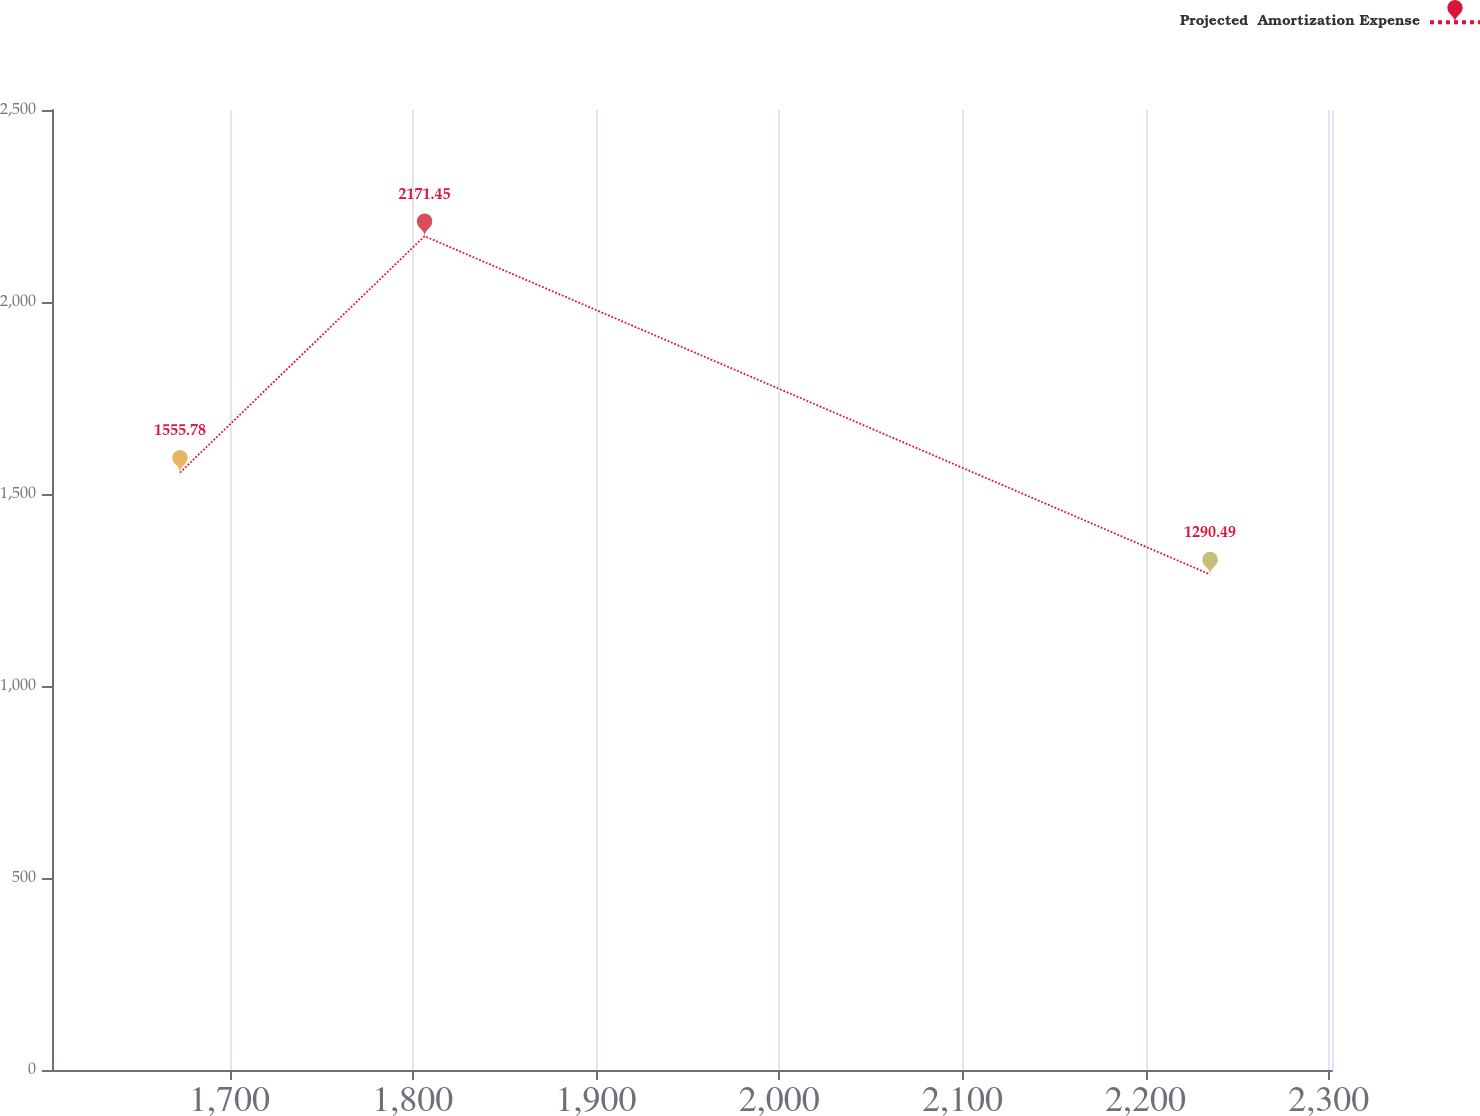Convert chart to OTSL. <chart><loc_0><loc_0><loc_500><loc_500><line_chart><ecel><fcel>Projected  Amortization Expense<nl><fcel>1672.92<fcel>1555.78<nl><fcel>1806.44<fcel>2171.45<nl><fcel>2235.2<fcel>1290.49<nl><fcel>2303.41<fcel>986.09<nl><fcel>2371.62<fcel>735.43<nl></chart> 